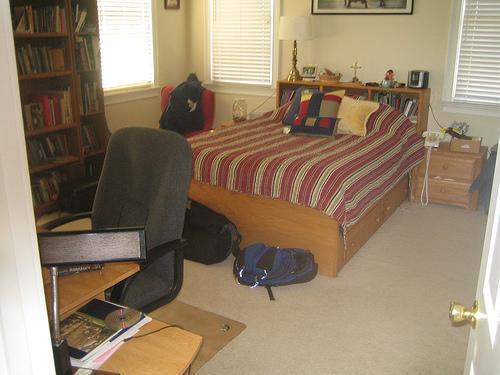How many backpacks can you see?
Give a very brief answer. 2. How many beds are in the picture?
Give a very brief answer. 1. How many people are holding an umbrella?
Give a very brief answer. 0. 